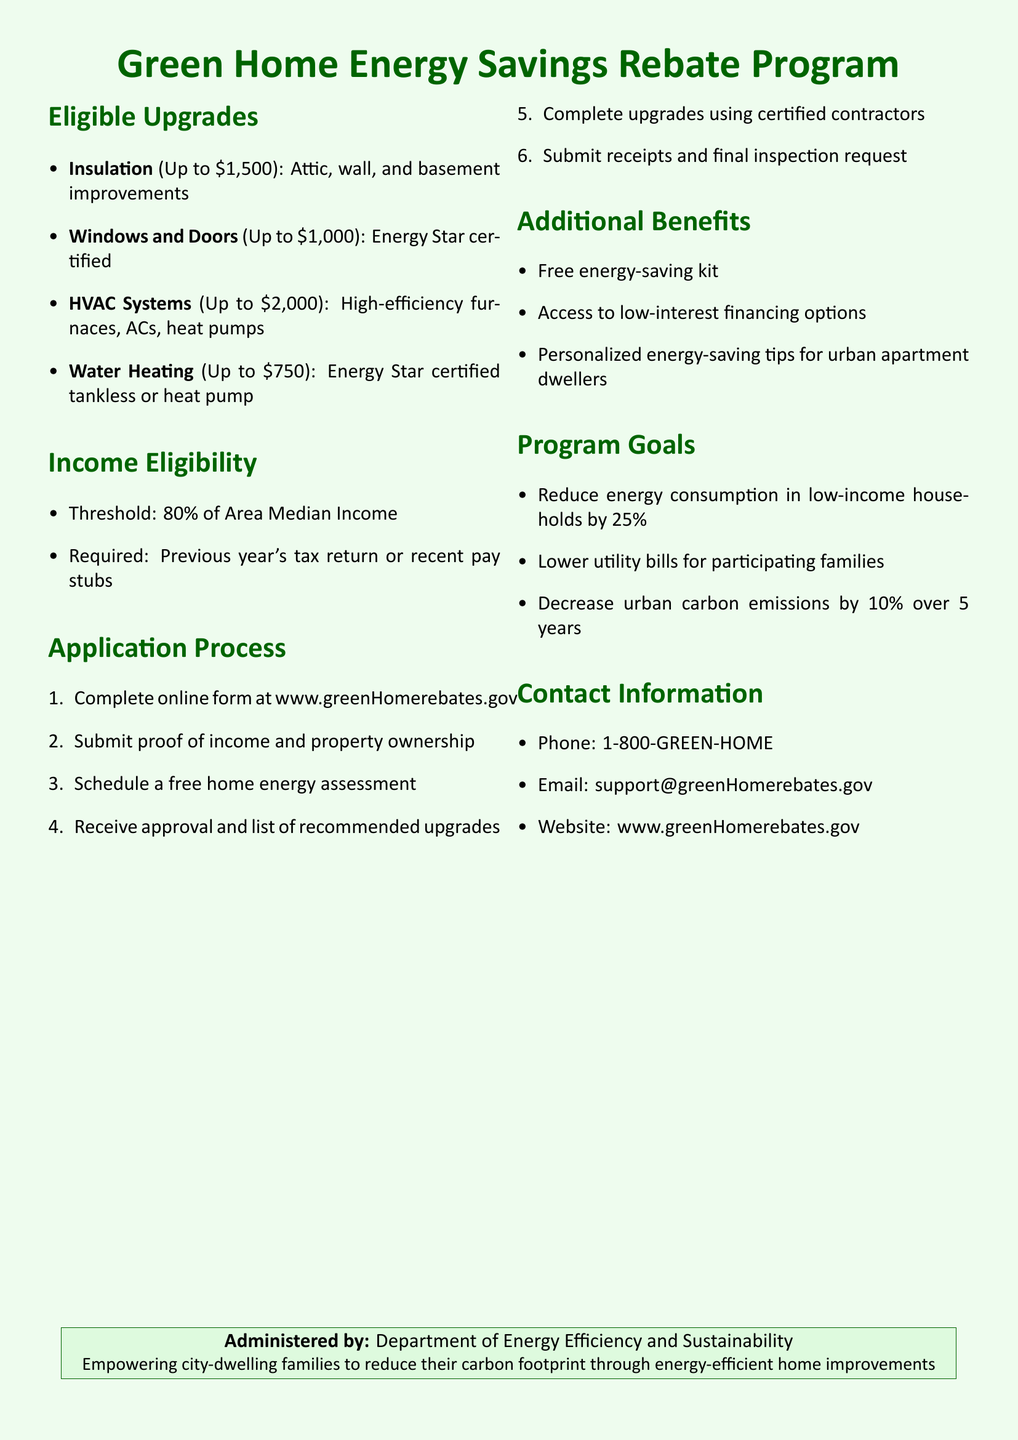what is the maximum rebate for HVAC systems? The maximum rebate amount for HVAC systems is specified in the Eligible Upgrades section of the document.
Answer: $2,000 what is the required income threshold for eligibility? The income eligibility threshold is mentioned in the Income Eligibility section of the document.
Answer: 80% of Area Median Income how many steps are in the application process? The document lists the steps in the Application Process section, which outlines the number of procedures applicants must follow.
Answer: 6 what type of heating systems are eligible for a rebate? Eligible heating systems can be found in the Eligible Upgrades section, detailing the types of systems that qualify.
Answer: High-efficiency furnaces, ACs, heat pumps what is provided to households as part of the additional benefits? The Additional Benefits section specifies what participants can receive to enhance their energy efficiency, as stated in the document.
Answer: Free energy-saving kit which organization administers the program? The administering entity is mentioned at the end of the document in the contact information section.
Answer: Department of Energy Efficiency and Sustainability what is the goal for reducing energy consumption in low-income households? The Program Goals section outlines the targeted percentage reduction in energy consumption for low-income families participating in the program.
Answer: 25% what is the contact phone number for the program? The contact information section includes the phone number that individuals can use for inquiries about the program.
Answer: 1-800-GREEN-HOME 